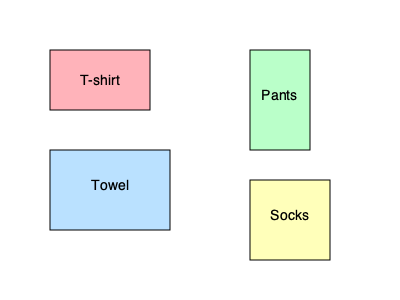Given the different shapes of clothing items shown above, which order of folding would be most efficient for a person using only one hand, considering the ease of stacking and minimizing movement? To determine the most efficient order for folding laundry with one hand, we need to consider the following factors:

1. Start with larger, easier-to-fold items: This allows for a stable base and requires less precision.
2. Progress to smaller items: Smaller items can be placed on top of larger ones more easily.
3. Minimize movement: Arrange the order to reduce the need for repositioning items.

Step-by-step folding order:

1. Towel: The largest and easiest item to fold with one hand. It provides a stable base for stacking.
2. T-shirt: Second largest item, can be folded in half and placed on the towel.
3. Pants: Can be folded lengthwise and placed on top of the T-shirt.
4. Socks: Smallest items, can be paired and placed on top of the stack.

This order minimizes movement and allows for efficient stacking, making it easier for someone with limited hand mobility to complete the task.
Answer: Towel, T-shirt, Pants, Socks 